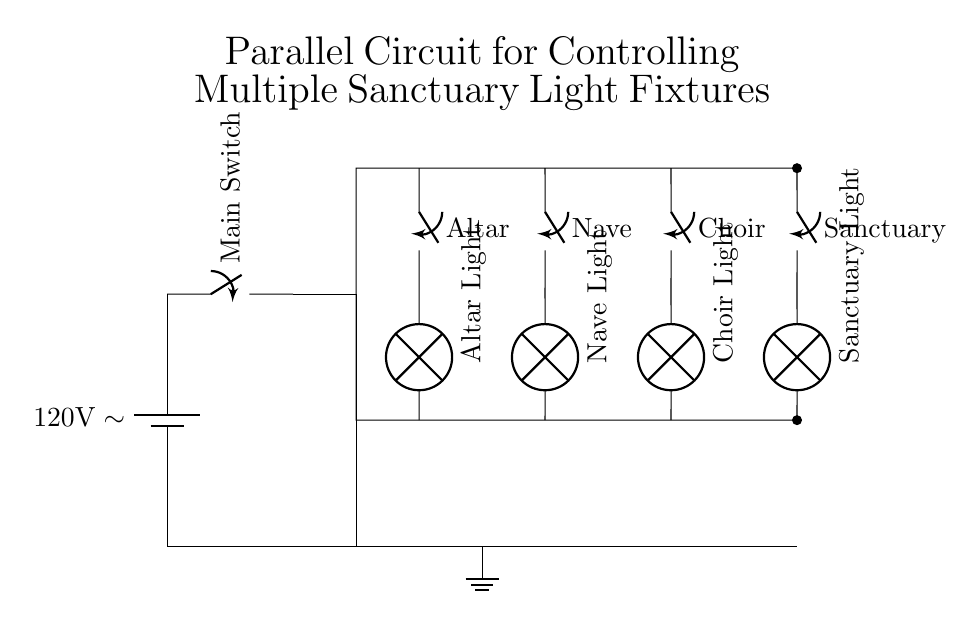What is the voltage of this circuit? The voltage is 120 volts, as indicated next to the battery symbol in the diagram. This signifies the power source voltage that will be supplied to the circuit.
Answer: 120 volts How many light fixtures are controlled in this circuit? There are four light fixtures shown in the diagram: Altar Light, Nave Light, Choir Light, and Sanctuary Light. Each is connected in parallel, allowing independent control.
Answer: 4 What type of switches are used in this circuit? The switches used in the circuit are labeled as standard switches, allowing for control of the connected light fixtures individually from one another.
Answer: switches How does the circuit maintain functionality if one light fixture fails? The circuit remains functional due to its parallel configuration; if one light fixture fails, the others continue to operate since each fixture has its own independent path for current flow.
Answer: It remains functional Which light fixture is connected to the switch labeled "Nave"? The switch labeled "Nave" controls the fixture called "Nave Light," as indicated by the connection from the switch directly to the lamp symbol.
Answer: Nave Light 